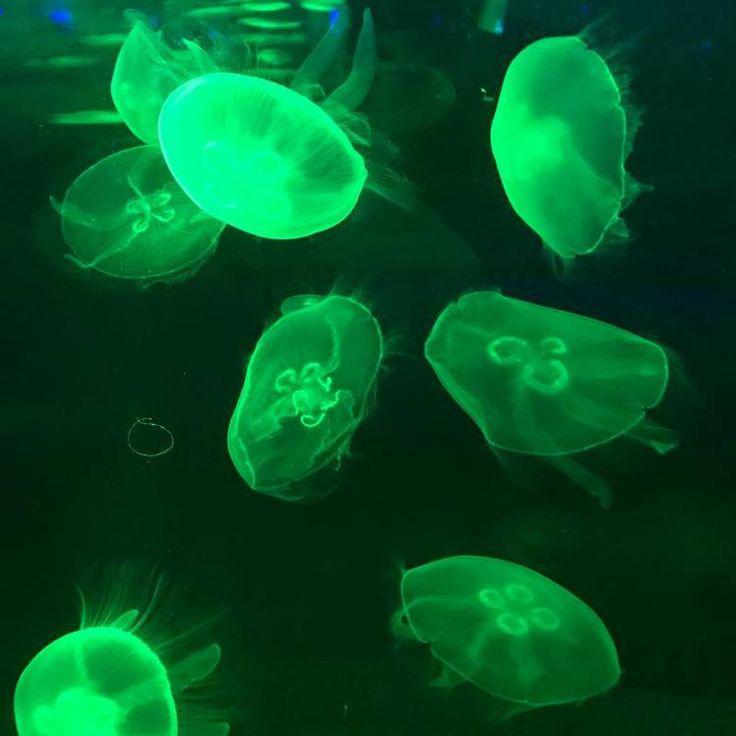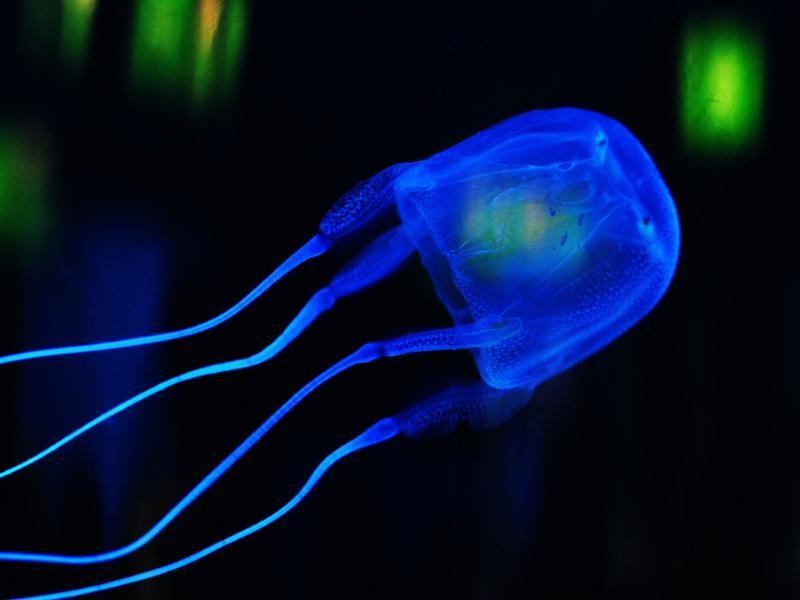The first image is the image on the left, the second image is the image on the right. Examine the images to the left and right. Is the description "multiple columned aquariums are holding jellyfish" accurate? Answer yes or no. No. The first image is the image on the left, the second image is the image on the right. Considering the images on both sides, is "An aquarium consists of multiple well lit geometrical shaped enclosures that have many types of sea creatures inside." valid? Answer yes or no. No. 